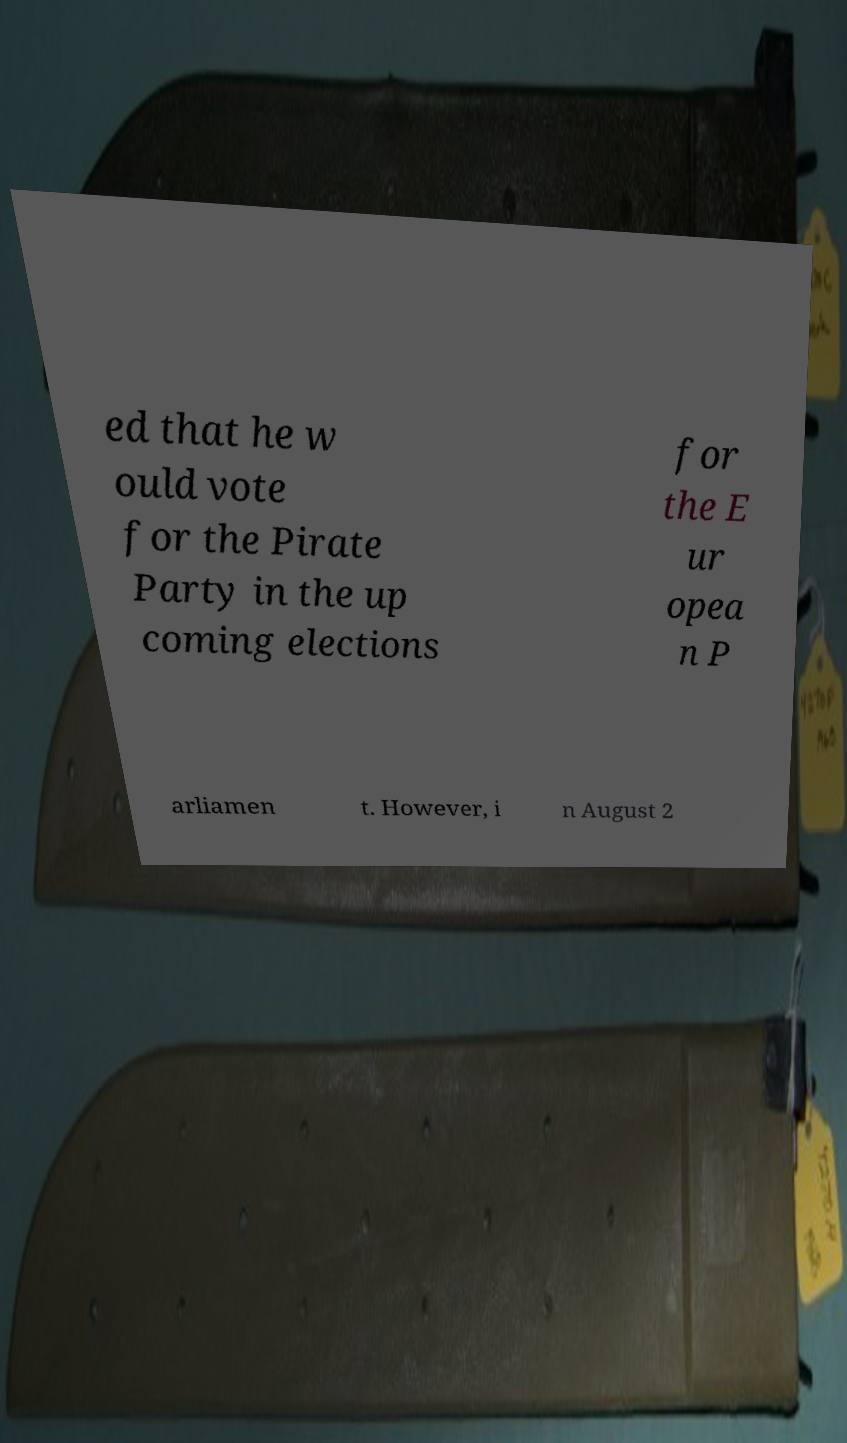Could you extract and type out the text from this image? ed that he w ould vote for the Pirate Party in the up coming elections for the E ur opea n P arliamen t. However, i n August 2 